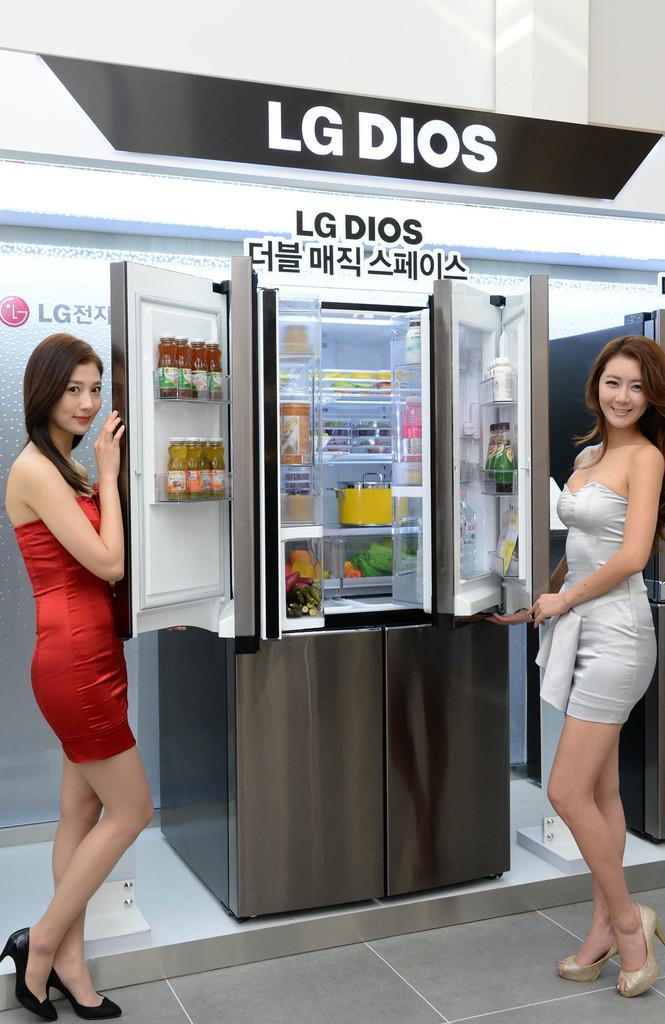<image>
Write a terse but informative summary of the picture. Two women in dresses stand in front of a model of the LG Dios. 